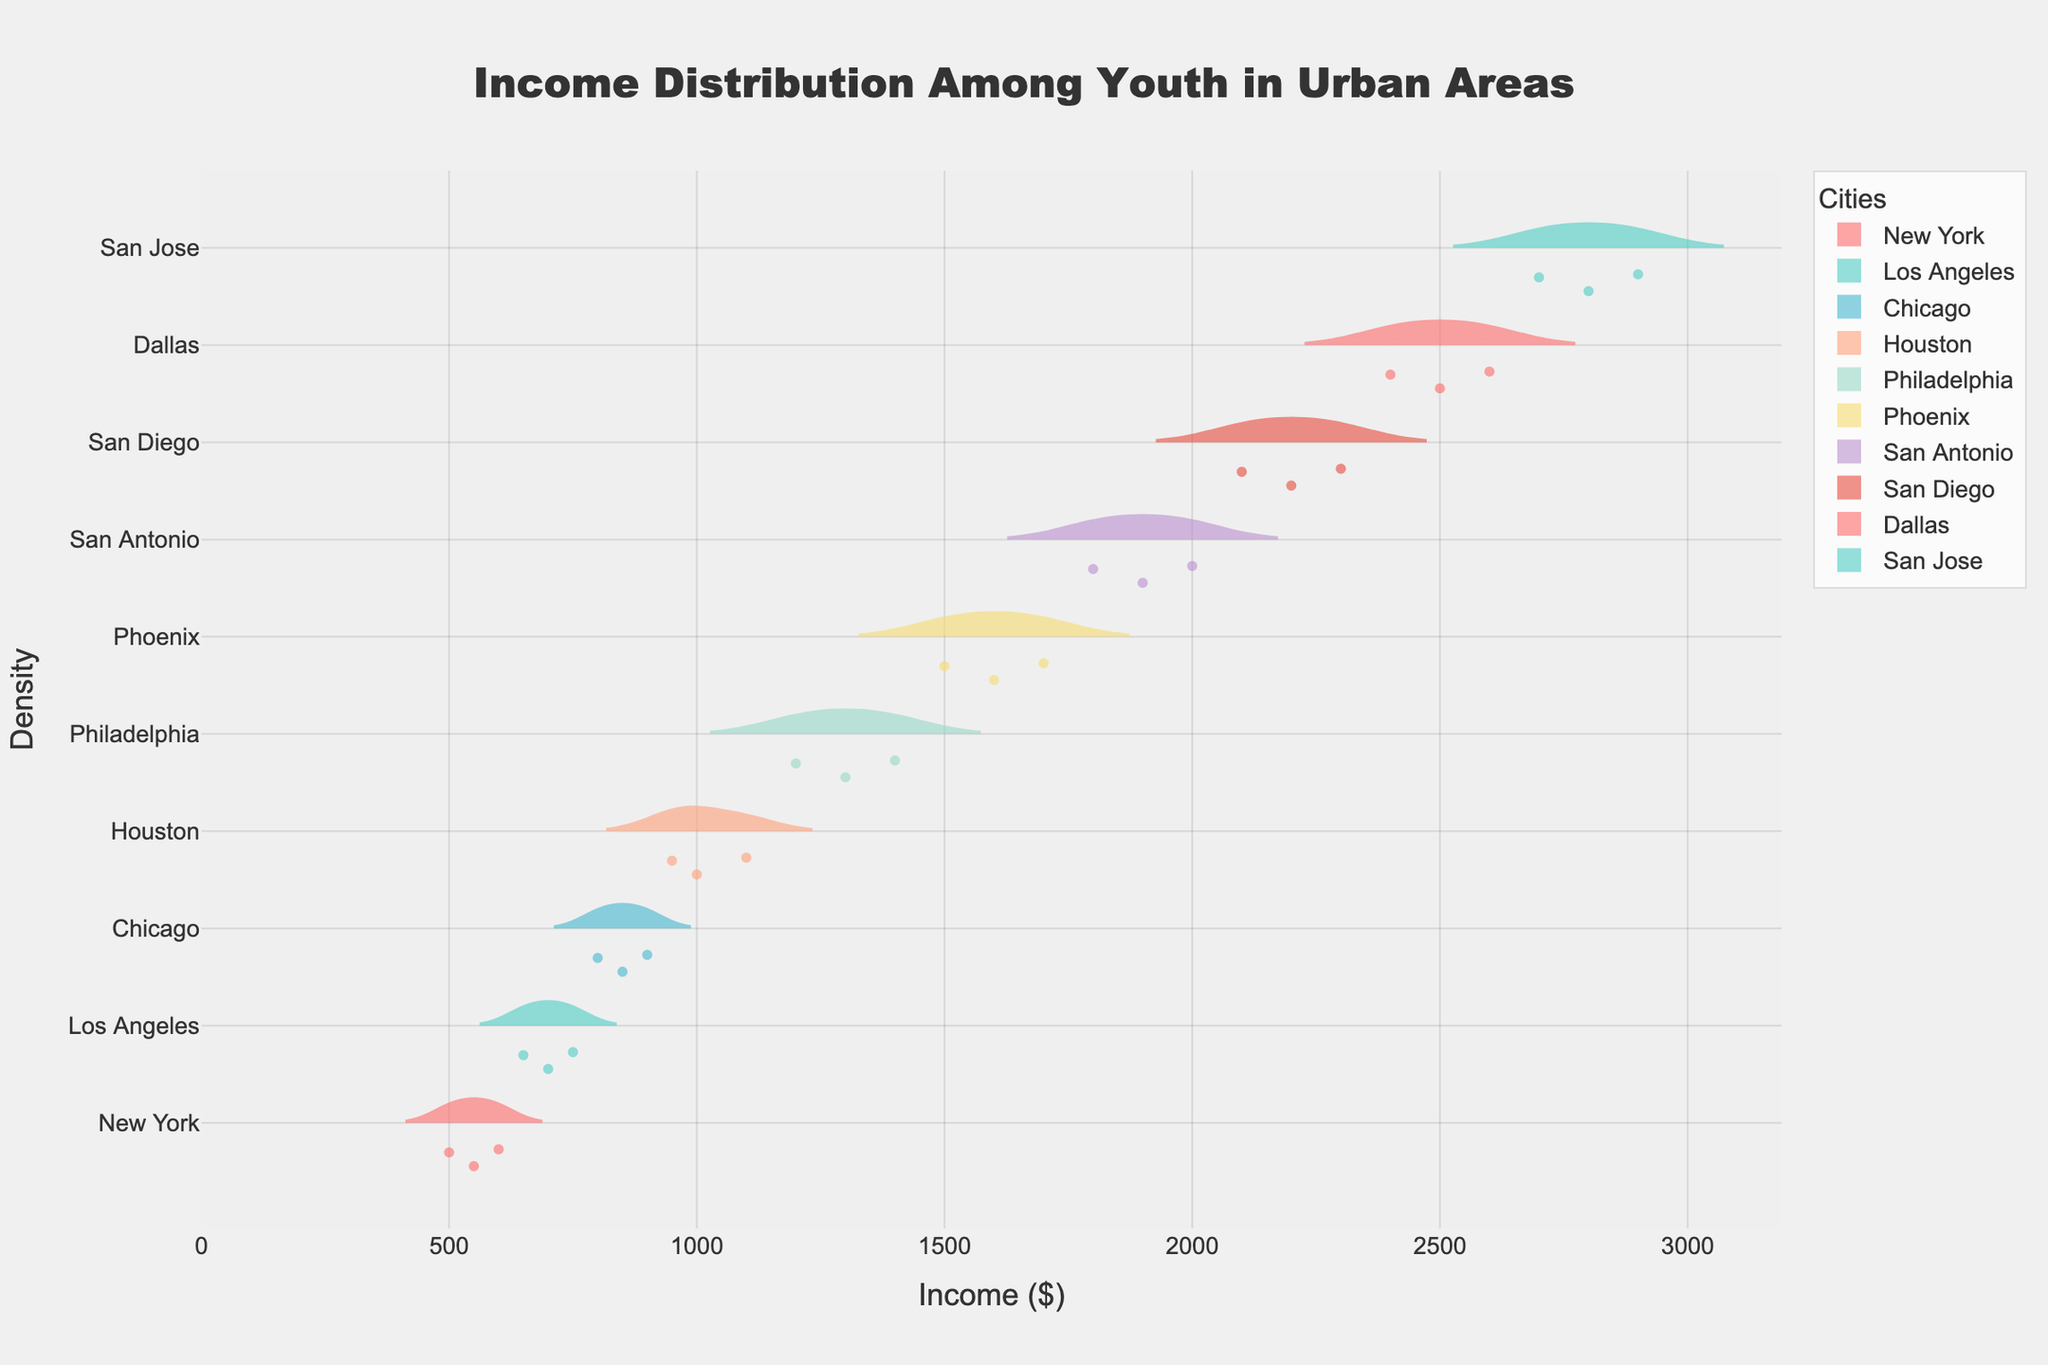What is the title of the plot? The title is located at the top of the plot. It gives an overview of what the plot is about. In this case, it mentions income distribution.
Answer: Income Distribution Among Youth in Urban Areas How many cities are represented in the plot? The legend on the plot indicates the different cities represented in the data. Each city has its own color.
Answer: 10 Which city has the highest range of income? By looking at the width of the violin plots, we can determine the range of incomes for each city. The city with the widest plot has the highest range.
Answer: San Jose Which city has the lowest income? The x-axis indicates income. By finding the lowest value on the x-axis and matching it to the corresponding city in the plot, we can identify this city.
Answer: New York What is the mean income for Houston? The plot shows a mean line within each violin plot. By locating the mean line for Houston, we can determine the mean income.
Answer: $1050 Which city has a higher median income: Dallas or Chicago? Each violin plot has a box that represents the interquartile range, with the median being the center line of this box. By comparing the positions of these medians, we can determine which is higher.
Answer: Dallas What is the range of incomes for Philadelphia? To find the range, we look at the minimum and maximum extents of the violin plot for Philadelphia on the x-axis and calculate the difference.
Answer: $1200 to $1400, range is $200 How does the income distribution in Los Angeles compare to that in Phoenix? By inspecting the shapes and sizes of the violin plots for Los Angeles and Phoenix, we can compare things like the spread and concentration of incomes.
Answer: Los Angeles has a narrower and more evenly distributed range, whereas Phoenix has a wider and more varied range Are there any cities with overlapping income ranges? By looking closely at the extents of the violin plots, we can see if any cities have income ranges that overlap with each other.
Answer: Yes What insights can be drawn about income inequality for the cities shown? Observing the width, spread, and mean lines of the violin plots helps in understanding income inequality. Cities with wider and more varied ranges demonstrate higher income inequality.
Answer: San Jose and Phoenix show higher income inequality, while Philadelphia and New York are more equal 